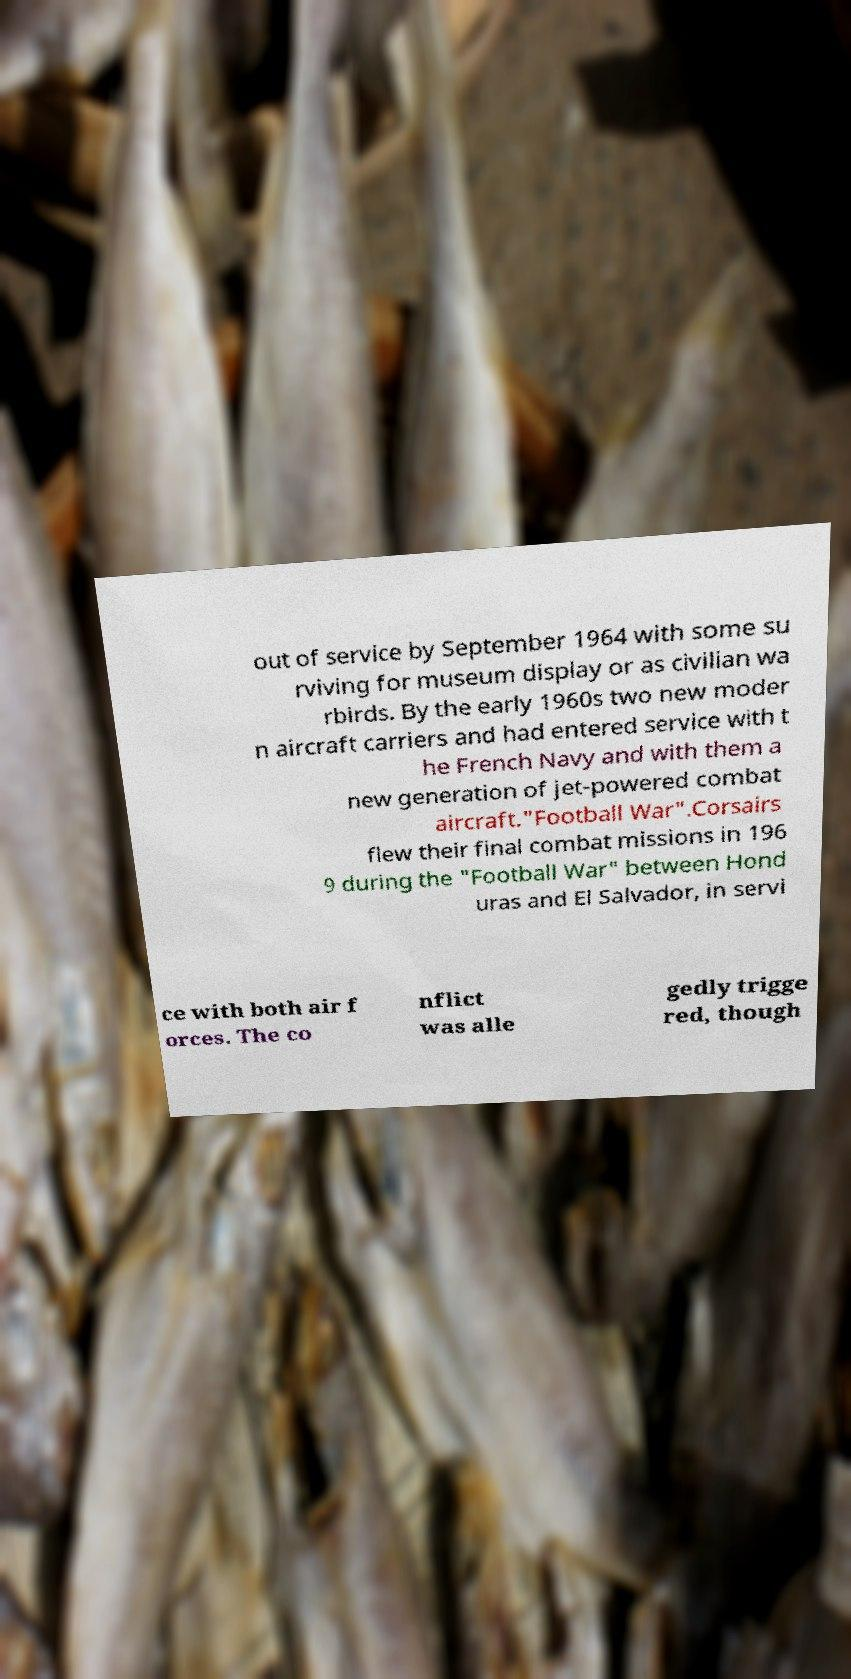What messages or text are displayed in this image? I need them in a readable, typed format. out of service by September 1964 with some su rviving for museum display or as civilian wa rbirds. By the early 1960s two new moder n aircraft carriers and had entered service with t he French Navy and with them a new generation of jet-powered combat aircraft."Football War".Corsairs flew their final combat missions in 196 9 during the "Football War" between Hond uras and El Salvador, in servi ce with both air f orces. The co nflict was alle gedly trigge red, though 